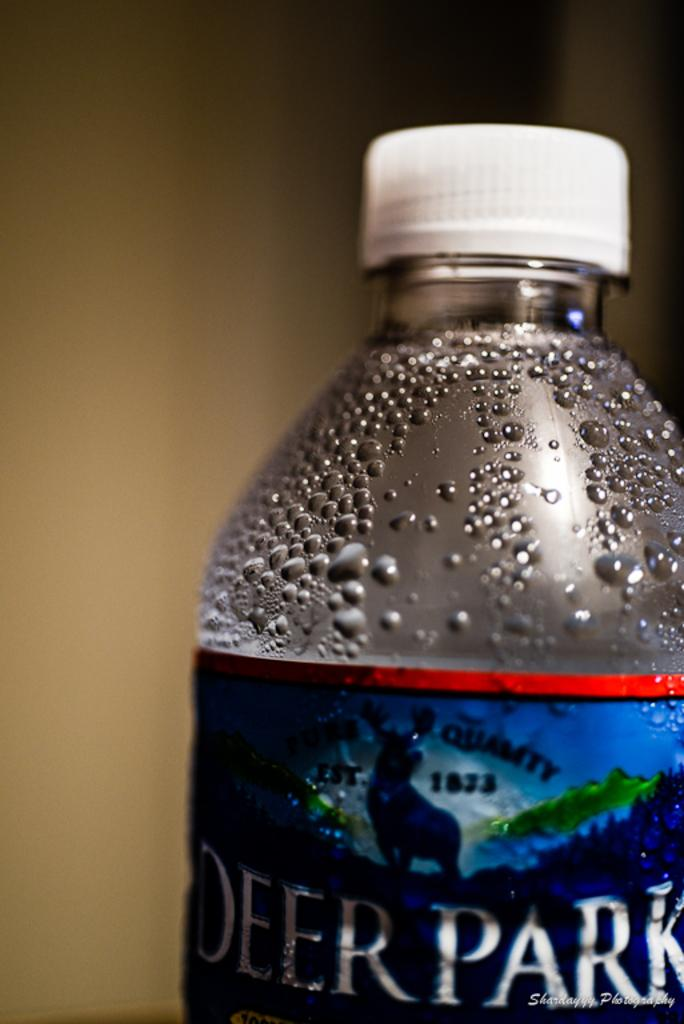<image>
Present a compact description of the photo's key features. Deer Park water has condesation building on the bottle 